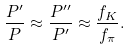<formula> <loc_0><loc_0><loc_500><loc_500>\frac { P ^ { \prime } } { P } \approx \frac { P ^ { \prime \prime } } { P ^ { \prime } } \approx \frac { f _ { K } } { f _ { \pi } } .</formula> 